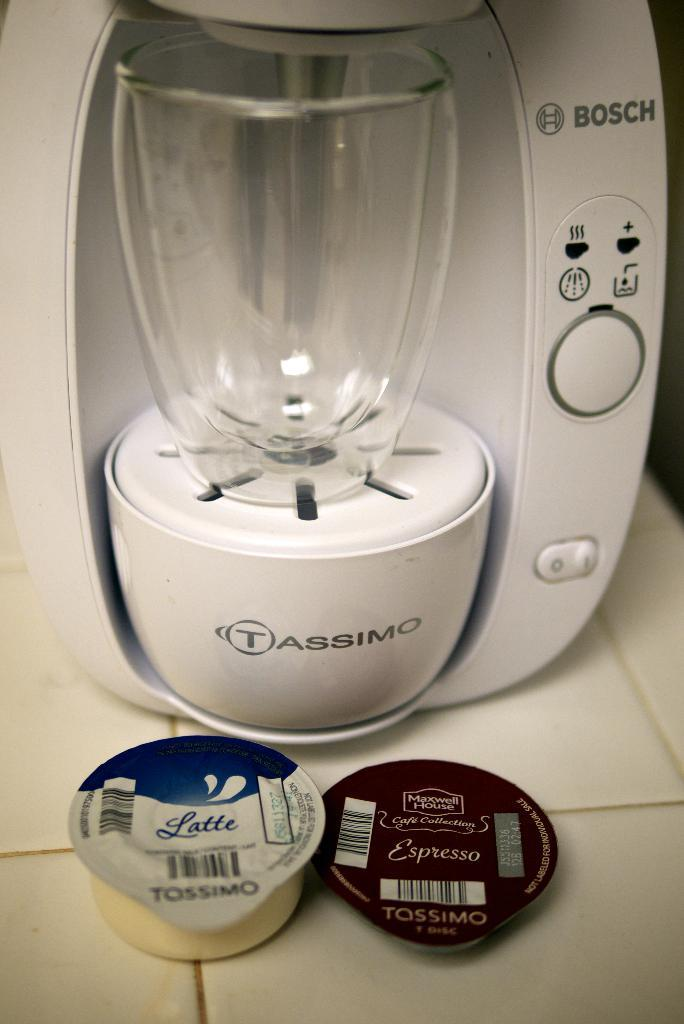What is the main object in the image? There is a white color machine in the image. What can be found on the machine? The machine has buttons and other objects attached to it. What might be used to hold or serve beverages in the image? There are cups on the surface of the machine or nearby. What type of crime is being committed in the image? There is no crime being committed in the image; it features a white color machine with buttons and cups. What kind of humor can be found in the image? There is no humor present in the image; it is a straightforward depiction of a machine with buttons and cups. 